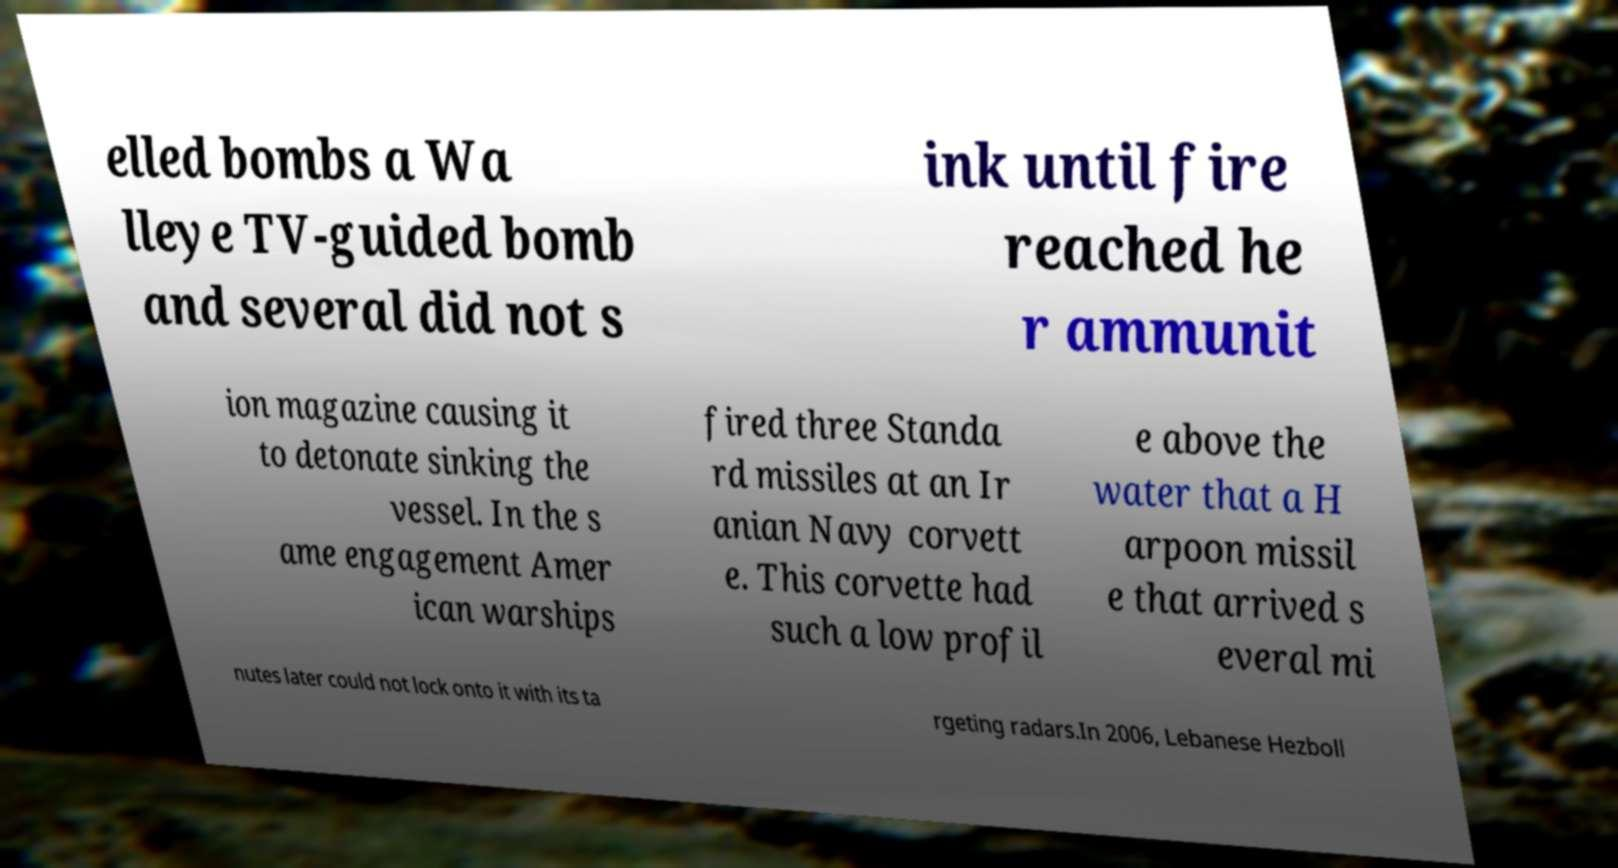Please identify and transcribe the text found in this image. elled bombs a Wa lleye TV-guided bomb and several did not s ink until fire reached he r ammunit ion magazine causing it to detonate sinking the vessel. In the s ame engagement Amer ican warships fired three Standa rd missiles at an Ir anian Navy corvett e. This corvette had such a low profil e above the water that a H arpoon missil e that arrived s everal mi nutes later could not lock onto it with its ta rgeting radars.In 2006, Lebanese Hezboll 